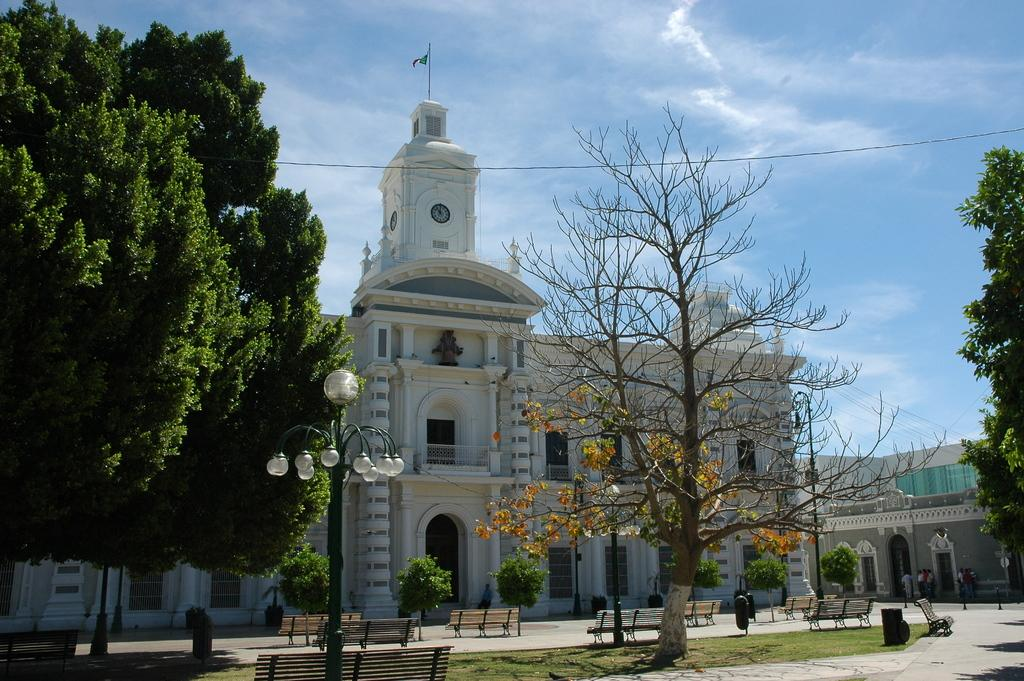What type of structures can be seen in the image? There are light poles, benches, bins, buildings, and a flag visible in the image. What type of vegetation is present in the image? There is grass and trees in the image. What can be seen on the buildings in the image? There are windows on the buildings in the image. What is the ground surface like in the image? There are people standing on the ground in the image. What is visible in the background of the image? The sky is visible in the background of the image. Can you tell me how many snails are crawling on the rose in the image? There is no rose or snails present in the image. What type of activity are the people engaged in on the grass in the image? The provided facts do not specify any activity the people are engaged in; they are simply standing on the ground. 